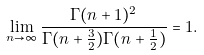<formula> <loc_0><loc_0><loc_500><loc_500>\lim _ { n \to \infty } \frac { \Gamma ( n + 1 ) ^ { 2 } } { \Gamma ( n + \frac { 3 } { 2 } ) \Gamma ( n + \frac { 1 } { 2 } ) } = 1 .</formula> 